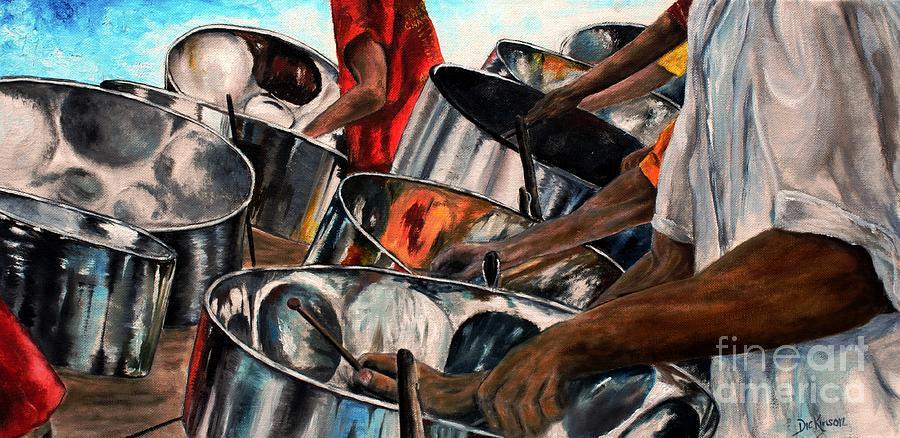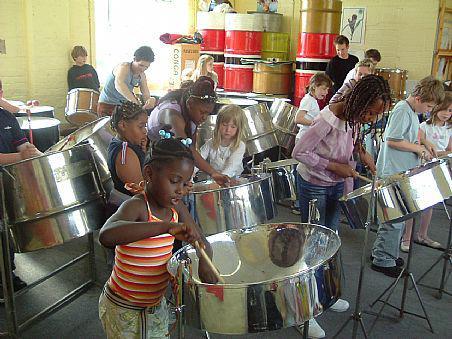The first image is the image on the left, the second image is the image on the right. Analyze the images presented: Is the assertion "A drummer is wearing a hat." valid? Answer yes or no. No. 